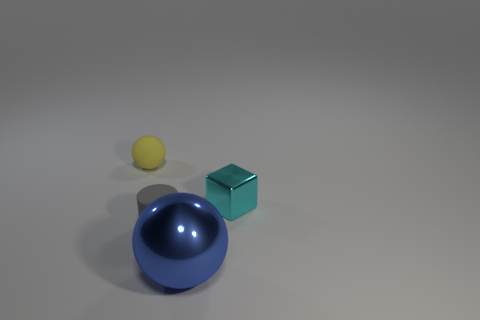Add 1 large brown objects. How many objects exist? 5 Subtract all cylinders. How many objects are left? 3 Subtract 1 cylinders. How many cylinders are left? 0 Subtract all cyan cylinders. How many yellow spheres are left? 1 Add 3 metal cubes. How many metal cubes are left? 4 Add 4 cyan cubes. How many cyan cubes exist? 5 Subtract 1 cyan cubes. How many objects are left? 3 Subtract all yellow balls. Subtract all cyan cylinders. How many balls are left? 1 Subtract all cyan cylinders. Subtract all tiny gray matte objects. How many objects are left? 3 